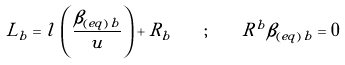Convert formula to latex. <formula><loc_0><loc_0><loc_500><loc_500>L _ { b } = l \, \left ( \frac { \beta _ { ( e q ) \, b } } { u } \right ) + R _ { b } \quad ; \quad R ^ { b } \beta _ { ( e q ) \, b } = 0</formula> 